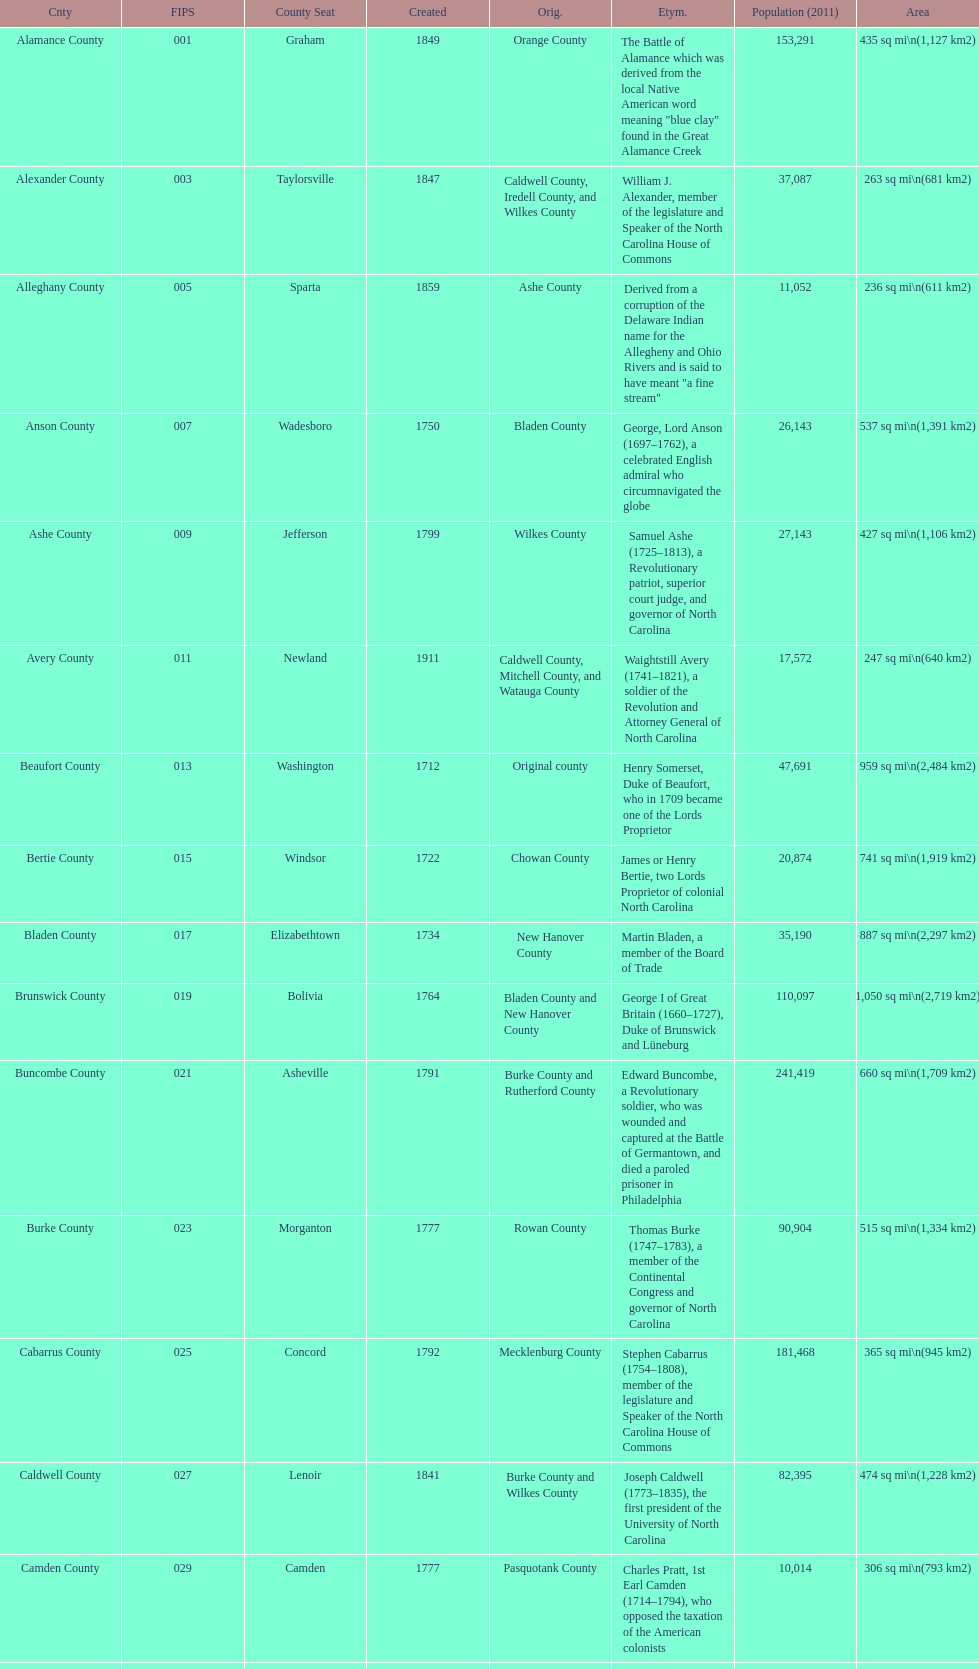Besides mecklenburg, which county has the most significant population? Wake County. 